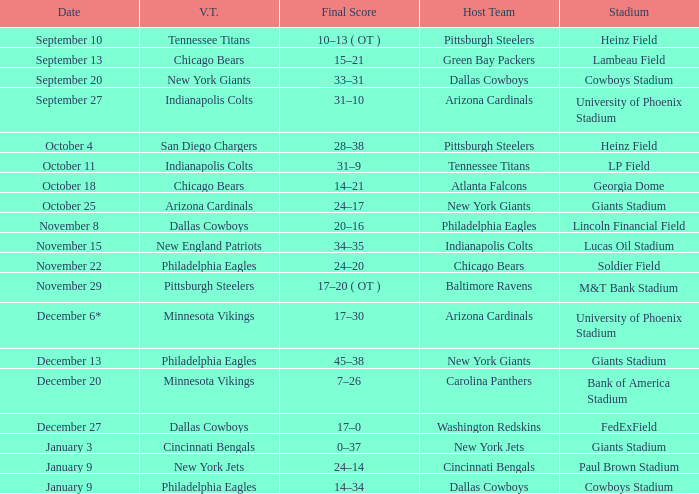Tell me the visiting team for october 4 San Diego Chargers. 